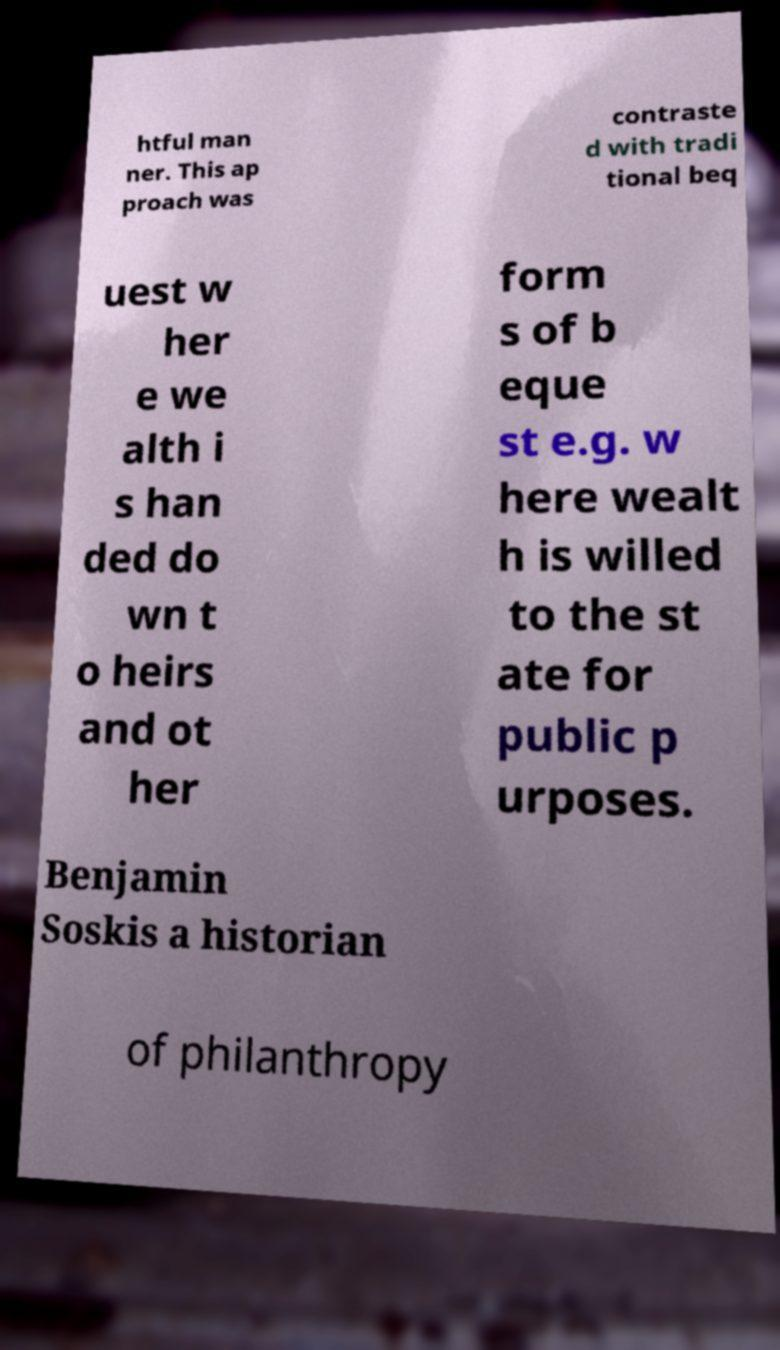Can you accurately transcribe the text from the provided image for me? htful man ner. This ap proach was contraste d with tradi tional beq uest w her e we alth i s han ded do wn t o heirs and ot her form s of b eque st e.g. w here wealt h is willed to the st ate for public p urposes. Benjamin Soskis a historian of philanthropy 